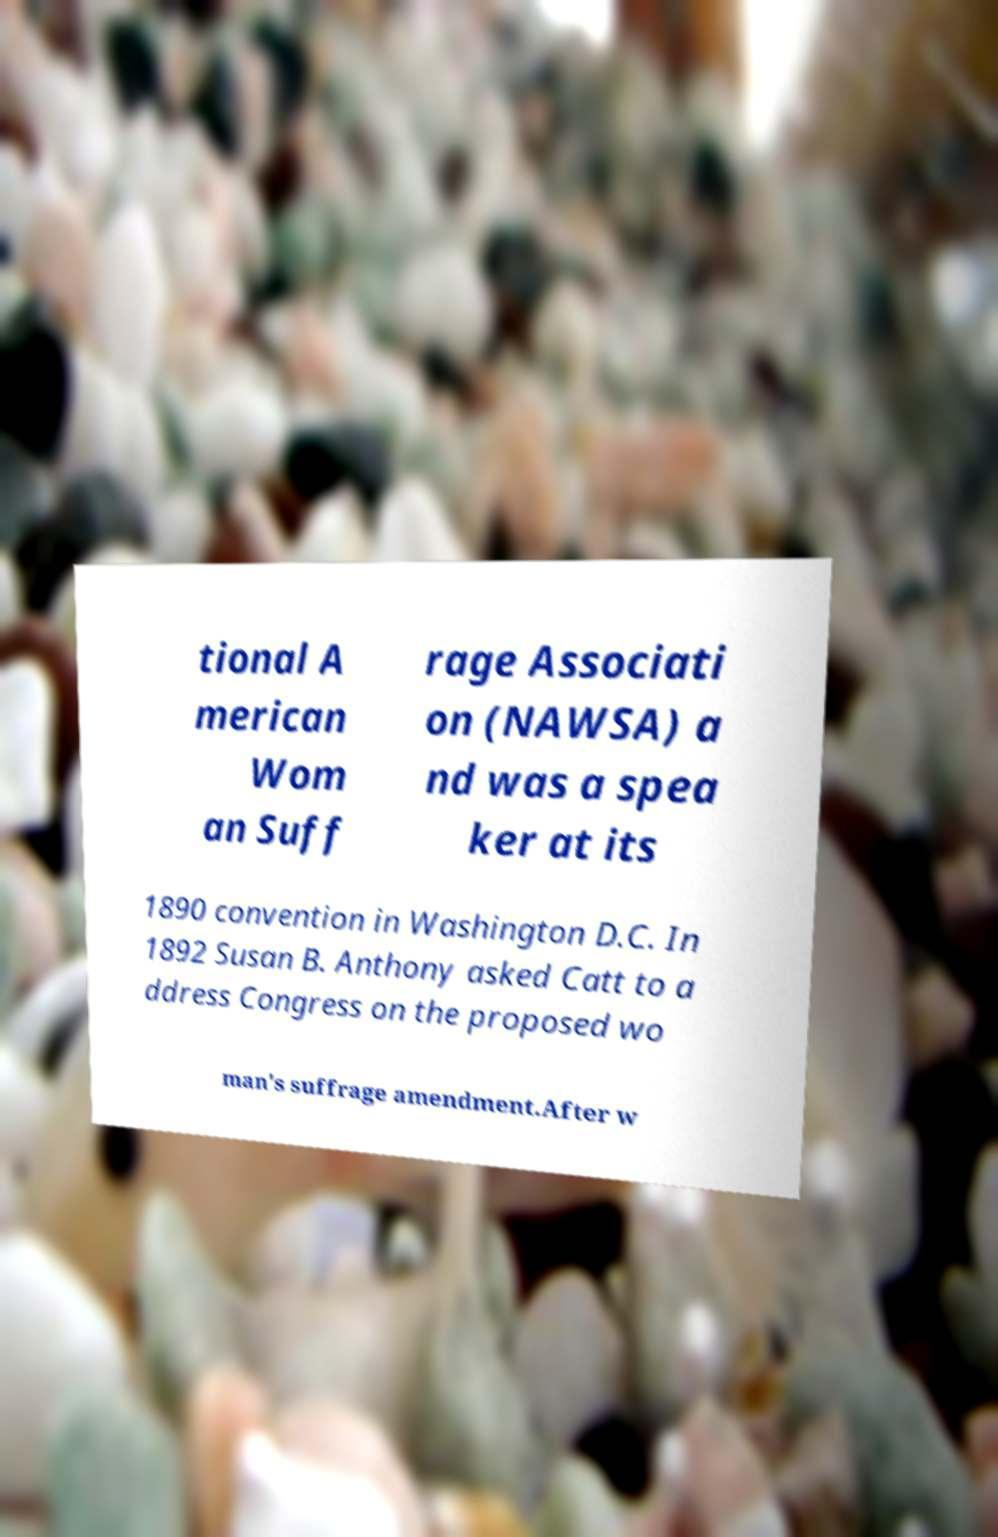Could you assist in decoding the text presented in this image and type it out clearly? tional A merican Wom an Suff rage Associati on (NAWSA) a nd was a spea ker at its 1890 convention in Washington D.C. In 1892 Susan B. Anthony asked Catt to a ddress Congress on the proposed wo man's suffrage amendment.After w 